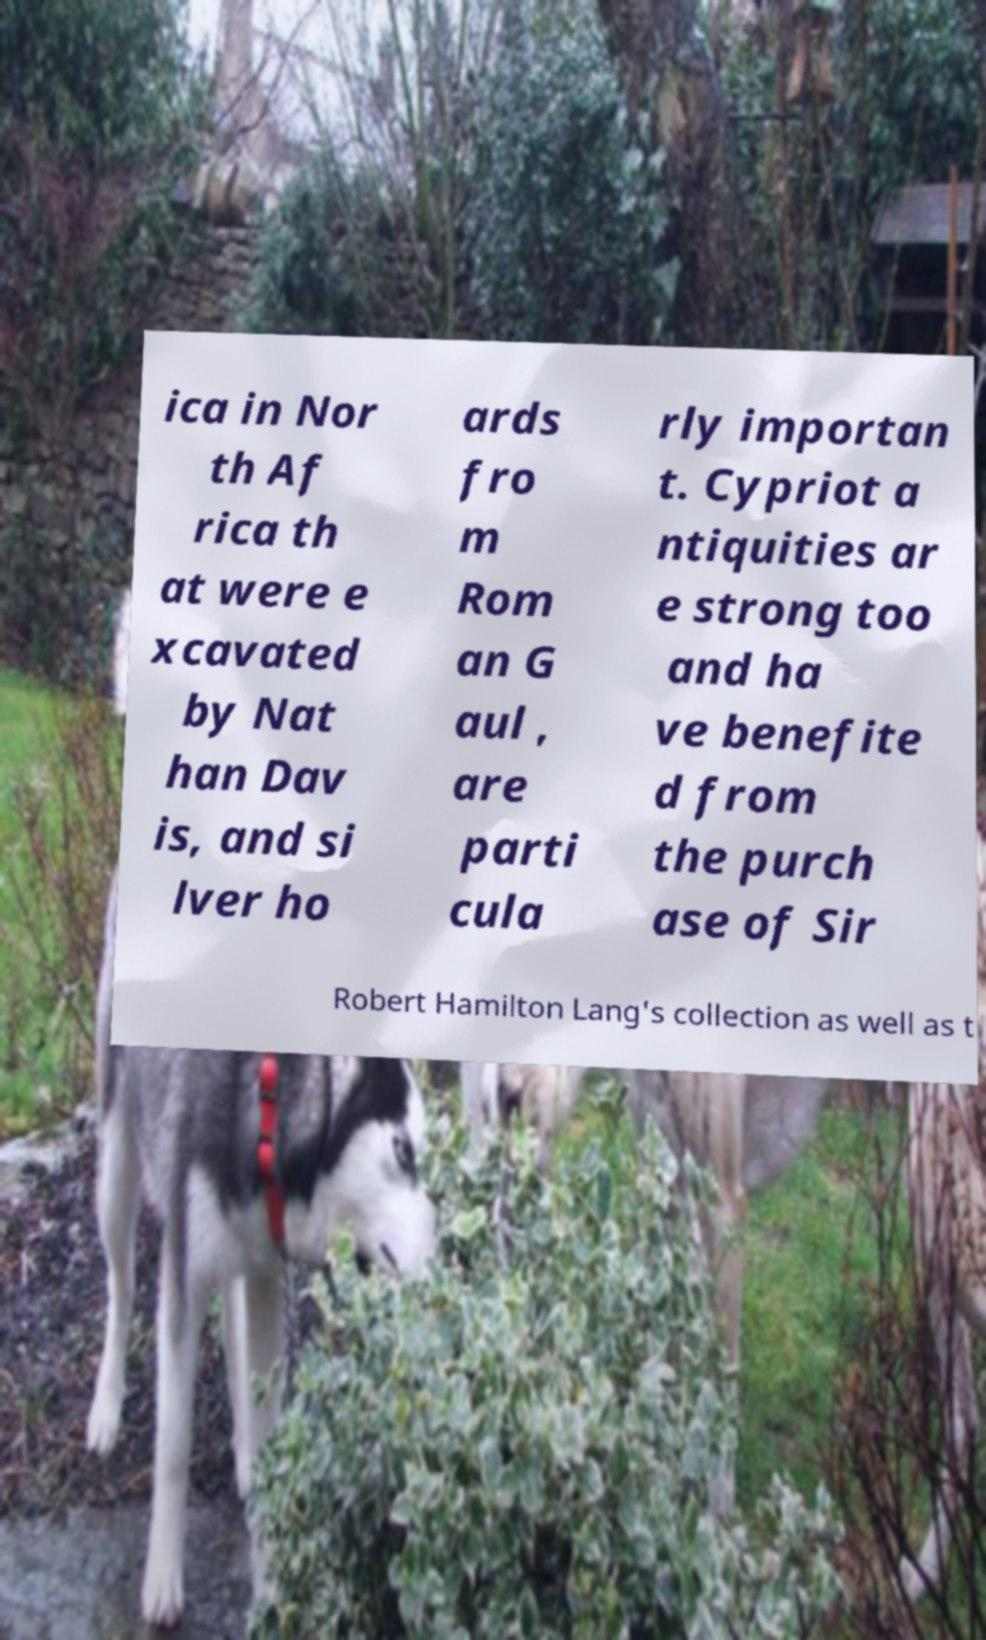I need the written content from this picture converted into text. Can you do that? ica in Nor th Af rica th at were e xcavated by Nat han Dav is, and si lver ho ards fro m Rom an G aul , are parti cula rly importan t. Cypriot a ntiquities ar e strong too and ha ve benefite d from the purch ase of Sir Robert Hamilton Lang's collection as well as t 